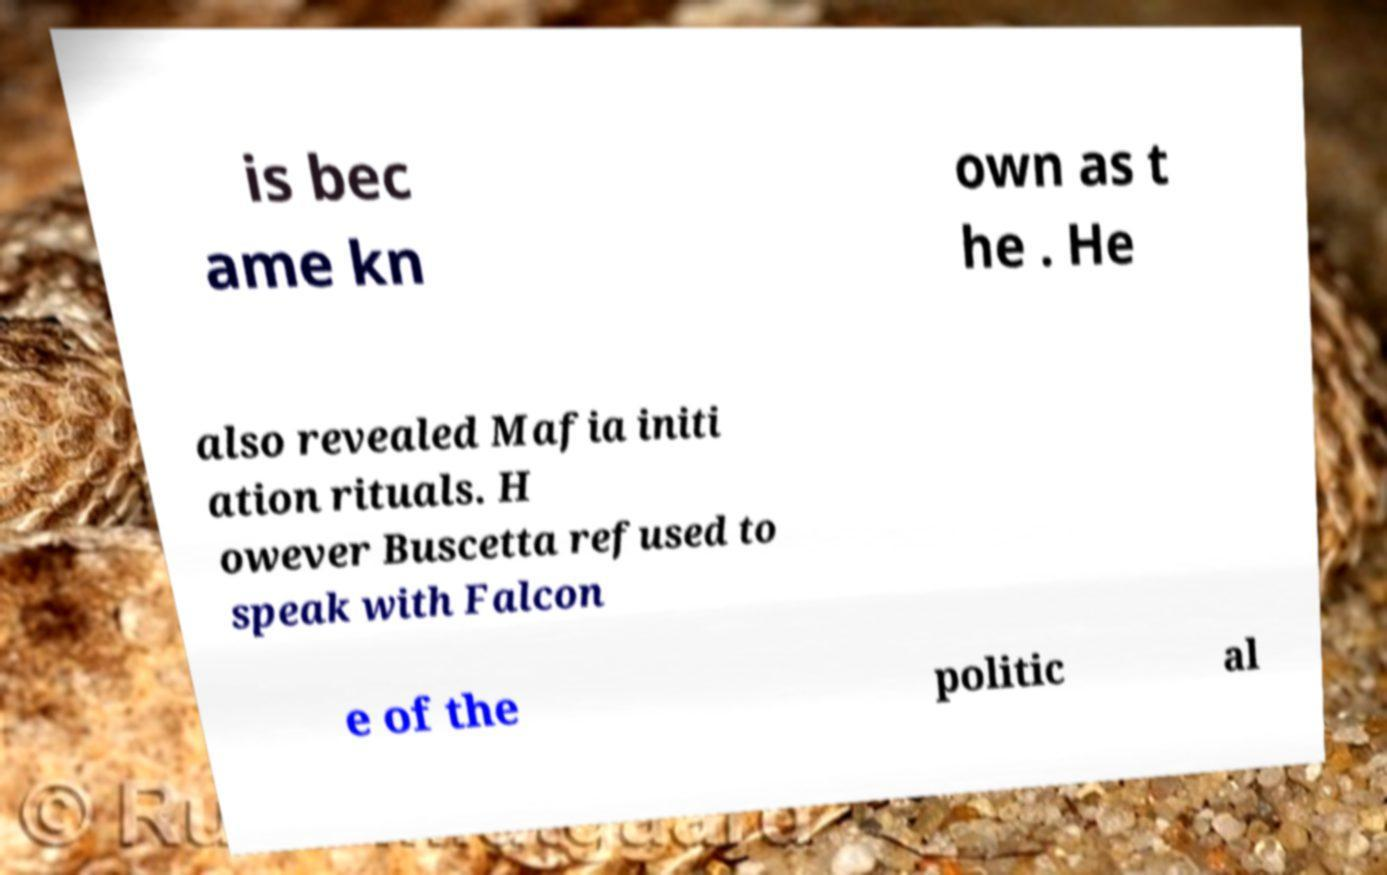I need the written content from this picture converted into text. Can you do that? is bec ame kn own as t he . He also revealed Mafia initi ation rituals. H owever Buscetta refused to speak with Falcon e of the politic al 